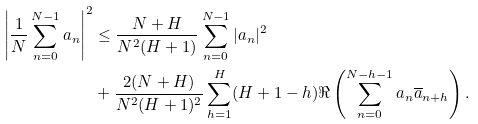Convert formula to latex. <formula><loc_0><loc_0><loc_500><loc_500>\left | \frac { 1 } { N } \sum _ { n = 0 } ^ { N - 1 } a _ { n } \right | ^ { 2 } & \leq \frac { N + H } { N ^ { 2 } ( H + 1 ) } \sum _ { n = 0 } ^ { N - 1 } | a _ { n } | ^ { 2 } \\ & + \frac { 2 ( N + H ) } { N ^ { 2 } ( H + 1 ) ^ { 2 } } \sum _ { h = 1 } ^ { H } ( H + 1 - h ) \Re \left ( \sum _ { n = 0 } ^ { N - h - 1 } a _ { n } \overline { a } _ { n + h } \right ) .</formula> 